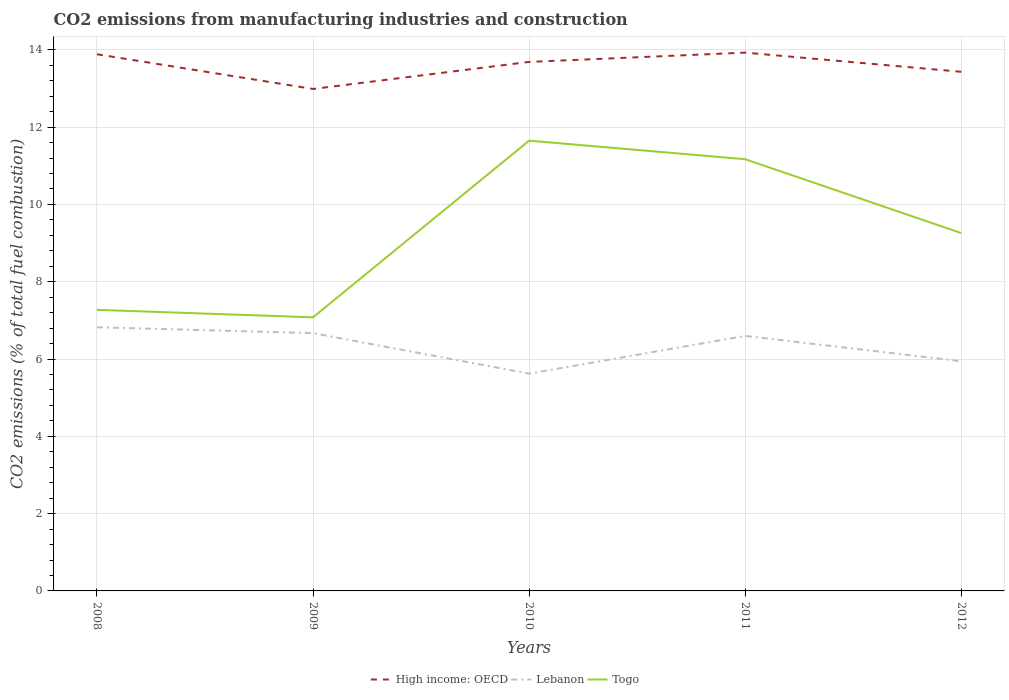How many different coloured lines are there?
Offer a terse response. 3. Across all years, what is the maximum amount of CO2 emitted in Lebanon?
Give a very brief answer. 5.62. In which year was the amount of CO2 emitted in High income: OECD maximum?
Keep it short and to the point. 2009. What is the total amount of CO2 emitted in Togo in the graph?
Provide a short and direct response. 2.39. What is the difference between the highest and the second highest amount of CO2 emitted in High income: OECD?
Offer a very short reply. 0.94. Is the amount of CO2 emitted in Togo strictly greater than the amount of CO2 emitted in Lebanon over the years?
Give a very brief answer. No. How many lines are there?
Offer a terse response. 3. How many years are there in the graph?
Keep it short and to the point. 5. What is the difference between two consecutive major ticks on the Y-axis?
Provide a short and direct response. 2. Where does the legend appear in the graph?
Provide a succinct answer. Bottom center. How are the legend labels stacked?
Your response must be concise. Horizontal. What is the title of the graph?
Your answer should be very brief. CO2 emissions from manufacturing industries and construction. What is the label or title of the Y-axis?
Provide a short and direct response. CO2 emissions (% of total fuel combustion). What is the CO2 emissions (% of total fuel combustion) of High income: OECD in 2008?
Keep it short and to the point. 13.89. What is the CO2 emissions (% of total fuel combustion) in Lebanon in 2008?
Ensure brevity in your answer.  6.82. What is the CO2 emissions (% of total fuel combustion) of Togo in 2008?
Your answer should be very brief. 7.27. What is the CO2 emissions (% of total fuel combustion) in High income: OECD in 2009?
Provide a succinct answer. 12.99. What is the CO2 emissions (% of total fuel combustion) in Lebanon in 2009?
Give a very brief answer. 6.67. What is the CO2 emissions (% of total fuel combustion) in Togo in 2009?
Provide a short and direct response. 7.08. What is the CO2 emissions (% of total fuel combustion) in High income: OECD in 2010?
Ensure brevity in your answer.  13.69. What is the CO2 emissions (% of total fuel combustion) in Lebanon in 2010?
Your response must be concise. 5.62. What is the CO2 emissions (% of total fuel combustion) in Togo in 2010?
Ensure brevity in your answer.  11.65. What is the CO2 emissions (% of total fuel combustion) in High income: OECD in 2011?
Keep it short and to the point. 13.93. What is the CO2 emissions (% of total fuel combustion) of Lebanon in 2011?
Keep it short and to the point. 6.6. What is the CO2 emissions (% of total fuel combustion) of Togo in 2011?
Keep it short and to the point. 11.17. What is the CO2 emissions (% of total fuel combustion) of High income: OECD in 2012?
Your answer should be very brief. 13.43. What is the CO2 emissions (% of total fuel combustion) in Lebanon in 2012?
Provide a succinct answer. 5.94. What is the CO2 emissions (% of total fuel combustion) in Togo in 2012?
Offer a very short reply. 9.26. Across all years, what is the maximum CO2 emissions (% of total fuel combustion) of High income: OECD?
Offer a very short reply. 13.93. Across all years, what is the maximum CO2 emissions (% of total fuel combustion) of Lebanon?
Your answer should be compact. 6.82. Across all years, what is the maximum CO2 emissions (% of total fuel combustion) of Togo?
Give a very brief answer. 11.65. Across all years, what is the minimum CO2 emissions (% of total fuel combustion) of High income: OECD?
Provide a short and direct response. 12.99. Across all years, what is the minimum CO2 emissions (% of total fuel combustion) of Lebanon?
Your response must be concise. 5.62. Across all years, what is the minimum CO2 emissions (% of total fuel combustion) in Togo?
Offer a terse response. 7.08. What is the total CO2 emissions (% of total fuel combustion) in High income: OECD in the graph?
Offer a terse response. 67.92. What is the total CO2 emissions (% of total fuel combustion) of Lebanon in the graph?
Ensure brevity in your answer.  31.66. What is the total CO2 emissions (% of total fuel combustion) of Togo in the graph?
Keep it short and to the point. 46.43. What is the difference between the CO2 emissions (% of total fuel combustion) of High income: OECD in 2008 and that in 2009?
Make the answer very short. 0.9. What is the difference between the CO2 emissions (% of total fuel combustion) in Lebanon in 2008 and that in 2009?
Give a very brief answer. 0.15. What is the difference between the CO2 emissions (% of total fuel combustion) of Togo in 2008 and that in 2009?
Your answer should be very brief. 0.19. What is the difference between the CO2 emissions (% of total fuel combustion) of High income: OECD in 2008 and that in 2010?
Your answer should be compact. 0.2. What is the difference between the CO2 emissions (% of total fuel combustion) in Lebanon in 2008 and that in 2010?
Keep it short and to the point. 1.2. What is the difference between the CO2 emissions (% of total fuel combustion) in Togo in 2008 and that in 2010?
Offer a very short reply. -4.38. What is the difference between the CO2 emissions (% of total fuel combustion) of High income: OECD in 2008 and that in 2011?
Your response must be concise. -0.04. What is the difference between the CO2 emissions (% of total fuel combustion) in Lebanon in 2008 and that in 2011?
Your answer should be very brief. 0.22. What is the difference between the CO2 emissions (% of total fuel combustion) in Togo in 2008 and that in 2011?
Your answer should be compact. -3.9. What is the difference between the CO2 emissions (% of total fuel combustion) of High income: OECD in 2008 and that in 2012?
Your answer should be very brief. 0.45. What is the difference between the CO2 emissions (% of total fuel combustion) of Lebanon in 2008 and that in 2012?
Make the answer very short. 0.88. What is the difference between the CO2 emissions (% of total fuel combustion) of Togo in 2008 and that in 2012?
Your answer should be very brief. -1.99. What is the difference between the CO2 emissions (% of total fuel combustion) of High income: OECD in 2009 and that in 2010?
Provide a succinct answer. -0.7. What is the difference between the CO2 emissions (% of total fuel combustion) in Lebanon in 2009 and that in 2010?
Ensure brevity in your answer.  1.05. What is the difference between the CO2 emissions (% of total fuel combustion) in Togo in 2009 and that in 2010?
Give a very brief answer. -4.57. What is the difference between the CO2 emissions (% of total fuel combustion) of High income: OECD in 2009 and that in 2011?
Make the answer very short. -0.94. What is the difference between the CO2 emissions (% of total fuel combustion) in Lebanon in 2009 and that in 2011?
Keep it short and to the point. 0.07. What is the difference between the CO2 emissions (% of total fuel combustion) in Togo in 2009 and that in 2011?
Provide a short and direct response. -4.09. What is the difference between the CO2 emissions (% of total fuel combustion) of High income: OECD in 2009 and that in 2012?
Ensure brevity in your answer.  -0.44. What is the difference between the CO2 emissions (% of total fuel combustion) of Lebanon in 2009 and that in 2012?
Ensure brevity in your answer.  0.73. What is the difference between the CO2 emissions (% of total fuel combustion) in Togo in 2009 and that in 2012?
Offer a terse response. -2.18. What is the difference between the CO2 emissions (% of total fuel combustion) in High income: OECD in 2010 and that in 2011?
Keep it short and to the point. -0.24. What is the difference between the CO2 emissions (% of total fuel combustion) of Lebanon in 2010 and that in 2011?
Offer a very short reply. -0.98. What is the difference between the CO2 emissions (% of total fuel combustion) of Togo in 2010 and that in 2011?
Make the answer very short. 0.48. What is the difference between the CO2 emissions (% of total fuel combustion) in High income: OECD in 2010 and that in 2012?
Provide a succinct answer. 0.26. What is the difference between the CO2 emissions (% of total fuel combustion) of Lebanon in 2010 and that in 2012?
Your answer should be compact. -0.32. What is the difference between the CO2 emissions (% of total fuel combustion) in Togo in 2010 and that in 2012?
Make the answer very short. 2.39. What is the difference between the CO2 emissions (% of total fuel combustion) in High income: OECD in 2011 and that in 2012?
Offer a terse response. 0.5. What is the difference between the CO2 emissions (% of total fuel combustion) of Lebanon in 2011 and that in 2012?
Keep it short and to the point. 0.65. What is the difference between the CO2 emissions (% of total fuel combustion) of Togo in 2011 and that in 2012?
Provide a succinct answer. 1.91. What is the difference between the CO2 emissions (% of total fuel combustion) of High income: OECD in 2008 and the CO2 emissions (% of total fuel combustion) of Lebanon in 2009?
Ensure brevity in your answer.  7.22. What is the difference between the CO2 emissions (% of total fuel combustion) in High income: OECD in 2008 and the CO2 emissions (% of total fuel combustion) in Togo in 2009?
Make the answer very short. 6.81. What is the difference between the CO2 emissions (% of total fuel combustion) of Lebanon in 2008 and the CO2 emissions (% of total fuel combustion) of Togo in 2009?
Ensure brevity in your answer.  -0.26. What is the difference between the CO2 emissions (% of total fuel combustion) of High income: OECD in 2008 and the CO2 emissions (% of total fuel combustion) of Lebanon in 2010?
Keep it short and to the point. 8.26. What is the difference between the CO2 emissions (% of total fuel combustion) in High income: OECD in 2008 and the CO2 emissions (% of total fuel combustion) in Togo in 2010?
Make the answer very short. 2.24. What is the difference between the CO2 emissions (% of total fuel combustion) in Lebanon in 2008 and the CO2 emissions (% of total fuel combustion) in Togo in 2010?
Provide a succinct answer. -4.83. What is the difference between the CO2 emissions (% of total fuel combustion) of High income: OECD in 2008 and the CO2 emissions (% of total fuel combustion) of Lebanon in 2011?
Make the answer very short. 7.29. What is the difference between the CO2 emissions (% of total fuel combustion) in High income: OECD in 2008 and the CO2 emissions (% of total fuel combustion) in Togo in 2011?
Your answer should be compact. 2.72. What is the difference between the CO2 emissions (% of total fuel combustion) in Lebanon in 2008 and the CO2 emissions (% of total fuel combustion) in Togo in 2011?
Make the answer very short. -4.35. What is the difference between the CO2 emissions (% of total fuel combustion) of High income: OECD in 2008 and the CO2 emissions (% of total fuel combustion) of Lebanon in 2012?
Your response must be concise. 7.94. What is the difference between the CO2 emissions (% of total fuel combustion) of High income: OECD in 2008 and the CO2 emissions (% of total fuel combustion) of Togo in 2012?
Your answer should be compact. 4.63. What is the difference between the CO2 emissions (% of total fuel combustion) of Lebanon in 2008 and the CO2 emissions (% of total fuel combustion) of Togo in 2012?
Provide a succinct answer. -2.44. What is the difference between the CO2 emissions (% of total fuel combustion) in High income: OECD in 2009 and the CO2 emissions (% of total fuel combustion) in Lebanon in 2010?
Provide a succinct answer. 7.37. What is the difference between the CO2 emissions (% of total fuel combustion) of High income: OECD in 2009 and the CO2 emissions (% of total fuel combustion) of Togo in 2010?
Your answer should be compact. 1.34. What is the difference between the CO2 emissions (% of total fuel combustion) in Lebanon in 2009 and the CO2 emissions (% of total fuel combustion) in Togo in 2010?
Offer a terse response. -4.98. What is the difference between the CO2 emissions (% of total fuel combustion) in High income: OECD in 2009 and the CO2 emissions (% of total fuel combustion) in Lebanon in 2011?
Give a very brief answer. 6.39. What is the difference between the CO2 emissions (% of total fuel combustion) of High income: OECD in 2009 and the CO2 emissions (% of total fuel combustion) of Togo in 2011?
Offer a terse response. 1.82. What is the difference between the CO2 emissions (% of total fuel combustion) of Lebanon in 2009 and the CO2 emissions (% of total fuel combustion) of Togo in 2011?
Your answer should be compact. -4.5. What is the difference between the CO2 emissions (% of total fuel combustion) of High income: OECD in 2009 and the CO2 emissions (% of total fuel combustion) of Lebanon in 2012?
Your response must be concise. 7.04. What is the difference between the CO2 emissions (% of total fuel combustion) in High income: OECD in 2009 and the CO2 emissions (% of total fuel combustion) in Togo in 2012?
Provide a short and direct response. 3.73. What is the difference between the CO2 emissions (% of total fuel combustion) in Lebanon in 2009 and the CO2 emissions (% of total fuel combustion) in Togo in 2012?
Make the answer very short. -2.59. What is the difference between the CO2 emissions (% of total fuel combustion) of High income: OECD in 2010 and the CO2 emissions (% of total fuel combustion) of Lebanon in 2011?
Ensure brevity in your answer.  7.09. What is the difference between the CO2 emissions (% of total fuel combustion) in High income: OECD in 2010 and the CO2 emissions (% of total fuel combustion) in Togo in 2011?
Offer a terse response. 2.52. What is the difference between the CO2 emissions (% of total fuel combustion) of Lebanon in 2010 and the CO2 emissions (% of total fuel combustion) of Togo in 2011?
Your response must be concise. -5.55. What is the difference between the CO2 emissions (% of total fuel combustion) of High income: OECD in 2010 and the CO2 emissions (% of total fuel combustion) of Lebanon in 2012?
Your answer should be compact. 7.74. What is the difference between the CO2 emissions (% of total fuel combustion) of High income: OECD in 2010 and the CO2 emissions (% of total fuel combustion) of Togo in 2012?
Provide a short and direct response. 4.43. What is the difference between the CO2 emissions (% of total fuel combustion) in Lebanon in 2010 and the CO2 emissions (% of total fuel combustion) in Togo in 2012?
Provide a short and direct response. -3.64. What is the difference between the CO2 emissions (% of total fuel combustion) of High income: OECD in 2011 and the CO2 emissions (% of total fuel combustion) of Lebanon in 2012?
Provide a succinct answer. 7.98. What is the difference between the CO2 emissions (% of total fuel combustion) of High income: OECD in 2011 and the CO2 emissions (% of total fuel combustion) of Togo in 2012?
Offer a terse response. 4.67. What is the difference between the CO2 emissions (% of total fuel combustion) in Lebanon in 2011 and the CO2 emissions (% of total fuel combustion) in Togo in 2012?
Offer a terse response. -2.66. What is the average CO2 emissions (% of total fuel combustion) in High income: OECD per year?
Provide a short and direct response. 13.58. What is the average CO2 emissions (% of total fuel combustion) of Lebanon per year?
Give a very brief answer. 6.33. What is the average CO2 emissions (% of total fuel combustion) of Togo per year?
Your answer should be compact. 9.29. In the year 2008, what is the difference between the CO2 emissions (% of total fuel combustion) in High income: OECD and CO2 emissions (% of total fuel combustion) in Lebanon?
Keep it short and to the point. 7.06. In the year 2008, what is the difference between the CO2 emissions (% of total fuel combustion) of High income: OECD and CO2 emissions (% of total fuel combustion) of Togo?
Ensure brevity in your answer.  6.61. In the year 2008, what is the difference between the CO2 emissions (% of total fuel combustion) in Lebanon and CO2 emissions (% of total fuel combustion) in Togo?
Make the answer very short. -0.45. In the year 2009, what is the difference between the CO2 emissions (% of total fuel combustion) of High income: OECD and CO2 emissions (% of total fuel combustion) of Lebanon?
Offer a terse response. 6.32. In the year 2009, what is the difference between the CO2 emissions (% of total fuel combustion) of High income: OECD and CO2 emissions (% of total fuel combustion) of Togo?
Provide a short and direct response. 5.91. In the year 2009, what is the difference between the CO2 emissions (% of total fuel combustion) of Lebanon and CO2 emissions (% of total fuel combustion) of Togo?
Provide a short and direct response. -0.41. In the year 2010, what is the difference between the CO2 emissions (% of total fuel combustion) of High income: OECD and CO2 emissions (% of total fuel combustion) of Lebanon?
Your answer should be very brief. 8.07. In the year 2010, what is the difference between the CO2 emissions (% of total fuel combustion) of High income: OECD and CO2 emissions (% of total fuel combustion) of Togo?
Ensure brevity in your answer.  2.04. In the year 2010, what is the difference between the CO2 emissions (% of total fuel combustion) in Lebanon and CO2 emissions (% of total fuel combustion) in Togo?
Your answer should be compact. -6.03. In the year 2011, what is the difference between the CO2 emissions (% of total fuel combustion) of High income: OECD and CO2 emissions (% of total fuel combustion) of Lebanon?
Make the answer very short. 7.33. In the year 2011, what is the difference between the CO2 emissions (% of total fuel combustion) in High income: OECD and CO2 emissions (% of total fuel combustion) in Togo?
Keep it short and to the point. 2.76. In the year 2011, what is the difference between the CO2 emissions (% of total fuel combustion) of Lebanon and CO2 emissions (% of total fuel combustion) of Togo?
Provide a short and direct response. -4.57. In the year 2012, what is the difference between the CO2 emissions (% of total fuel combustion) in High income: OECD and CO2 emissions (% of total fuel combustion) in Lebanon?
Your answer should be very brief. 7.49. In the year 2012, what is the difference between the CO2 emissions (% of total fuel combustion) of High income: OECD and CO2 emissions (% of total fuel combustion) of Togo?
Ensure brevity in your answer.  4.17. In the year 2012, what is the difference between the CO2 emissions (% of total fuel combustion) of Lebanon and CO2 emissions (% of total fuel combustion) of Togo?
Offer a terse response. -3.32. What is the ratio of the CO2 emissions (% of total fuel combustion) in High income: OECD in 2008 to that in 2009?
Offer a terse response. 1.07. What is the ratio of the CO2 emissions (% of total fuel combustion) in Lebanon in 2008 to that in 2009?
Give a very brief answer. 1.02. What is the ratio of the CO2 emissions (% of total fuel combustion) in Togo in 2008 to that in 2009?
Give a very brief answer. 1.03. What is the ratio of the CO2 emissions (% of total fuel combustion) in High income: OECD in 2008 to that in 2010?
Ensure brevity in your answer.  1.01. What is the ratio of the CO2 emissions (% of total fuel combustion) in Lebanon in 2008 to that in 2010?
Your answer should be very brief. 1.21. What is the ratio of the CO2 emissions (% of total fuel combustion) of Togo in 2008 to that in 2010?
Ensure brevity in your answer.  0.62. What is the ratio of the CO2 emissions (% of total fuel combustion) in Lebanon in 2008 to that in 2011?
Give a very brief answer. 1.03. What is the ratio of the CO2 emissions (% of total fuel combustion) in Togo in 2008 to that in 2011?
Your answer should be very brief. 0.65. What is the ratio of the CO2 emissions (% of total fuel combustion) of High income: OECD in 2008 to that in 2012?
Provide a short and direct response. 1.03. What is the ratio of the CO2 emissions (% of total fuel combustion) in Lebanon in 2008 to that in 2012?
Give a very brief answer. 1.15. What is the ratio of the CO2 emissions (% of total fuel combustion) of Togo in 2008 to that in 2012?
Your answer should be compact. 0.79. What is the ratio of the CO2 emissions (% of total fuel combustion) of High income: OECD in 2009 to that in 2010?
Provide a short and direct response. 0.95. What is the ratio of the CO2 emissions (% of total fuel combustion) of Lebanon in 2009 to that in 2010?
Offer a terse response. 1.19. What is the ratio of the CO2 emissions (% of total fuel combustion) of Togo in 2009 to that in 2010?
Your answer should be very brief. 0.61. What is the ratio of the CO2 emissions (% of total fuel combustion) of High income: OECD in 2009 to that in 2011?
Your answer should be very brief. 0.93. What is the ratio of the CO2 emissions (% of total fuel combustion) in Lebanon in 2009 to that in 2011?
Provide a succinct answer. 1.01. What is the ratio of the CO2 emissions (% of total fuel combustion) in Togo in 2009 to that in 2011?
Your answer should be very brief. 0.63. What is the ratio of the CO2 emissions (% of total fuel combustion) of High income: OECD in 2009 to that in 2012?
Your response must be concise. 0.97. What is the ratio of the CO2 emissions (% of total fuel combustion) of Lebanon in 2009 to that in 2012?
Offer a very short reply. 1.12. What is the ratio of the CO2 emissions (% of total fuel combustion) in Togo in 2009 to that in 2012?
Ensure brevity in your answer.  0.76. What is the ratio of the CO2 emissions (% of total fuel combustion) in High income: OECD in 2010 to that in 2011?
Give a very brief answer. 0.98. What is the ratio of the CO2 emissions (% of total fuel combustion) in Lebanon in 2010 to that in 2011?
Offer a very short reply. 0.85. What is the ratio of the CO2 emissions (% of total fuel combustion) in Togo in 2010 to that in 2011?
Your answer should be compact. 1.04. What is the ratio of the CO2 emissions (% of total fuel combustion) in High income: OECD in 2010 to that in 2012?
Your response must be concise. 1.02. What is the ratio of the CO2 emissions (% of total fuel combustion) of Lebanon in 2010 to that in 2012?
Give a very brief answer. 0.95. What is the ratio of the CO2 emissions (% of total fuel combustion) of Togo in 2010 to that in 2012?
Offer a very short reply. 1.26. What is the ratio of the CO2 emissions (% of total fuel combustion) in High income: OECD in 2011 to that in 2012?
Provide a succinct answer. 1.04. What is the ratio of the CO2 emissions (% of total fuel combustion) of Lebanon in 2011 to that in 2012?
Keep it short and to the point. 1.11. What is the ratio of the CO2 emissions (% of total fuel combustion) of Togo in 2011 to that in 2012?
Offer a terse response. 1.21. What is the difference between the highest and the second highest CO2 emissions (% of total fuel combustion) of High income: OECD?
Offer a very short reply. 0.04. What is the difference between the highest and the second highest CO2 emissions (% of total fuel combustion) of Lebanon?
Make the answer very short. 0.15. What is the difference between the highest and the second highest CO2 emissions (% of total fuel combustion) of Togo?
Give a very brief answer. 0.48. What is the difference between the highest and the lowest CO2 emissions (% of total fuel combustion) of High income: OECD?
Give a very brief answer. 0.94. What is the difference between the highest and the lowest CO2 emissions (% of total fuel combustion) of Lebanon?
Your response must be concise. 1.2. What is the difference between the highest and the lowest CO2 emissions (% of total fuel combustion) of Togo?
Provide a succinct answer. 4.57. 